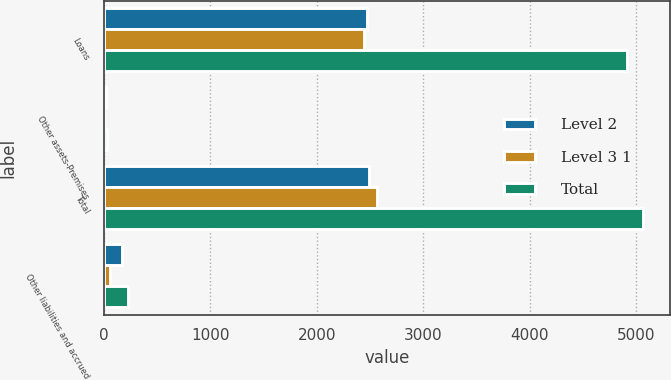<chart> <loc_0><loc_0><loc_500><loc_500><stacked_bar_chart><ecel><fcel>Loans<fcel>Other assets-Premises<fcel>Total<fcel>Other liabilities and accrued<nl><fcel>Level 2<fcel>2470<fcel>22<fcel>2492<fcel>166<nl><fcel>Level 3 1<fcel>2443<fcel>3<fcel>2569<fcel>60<nl><fcel>Total<fcel>4913<fcel>25<fcel>5061<fcel>226<nl></chart> 